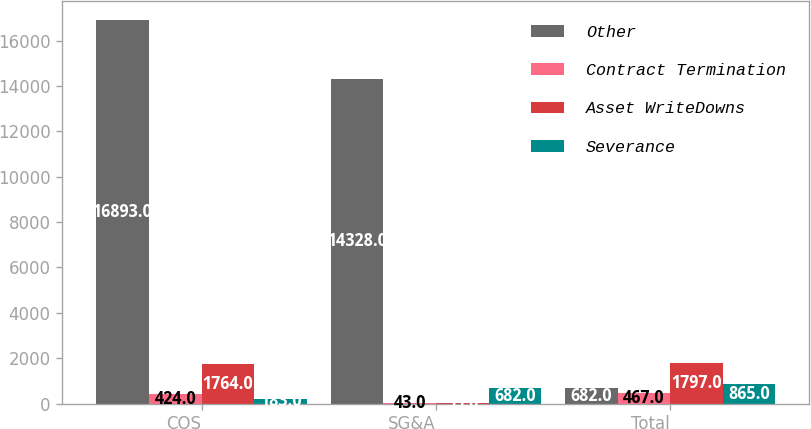Convert chart to OTSL. <chart><loc_0><loc_0><loc_500><loc_500><stacked_bar_chart><ecel><fcel>COS<fcel>SG&A<fcel>Total<nl><fcel>Other<fcel>16893<fcel>14328<fcel>682<nl><fcel>Contract Termination<fcel>424<fcel>43<fcel>467<nl><fcel>Asset WriteDowns<fcel>1764<fcel>33<fcel>1797<nl><fcel>Severance<fcel>183<fcel>682<fcel>865<nl></chart> 